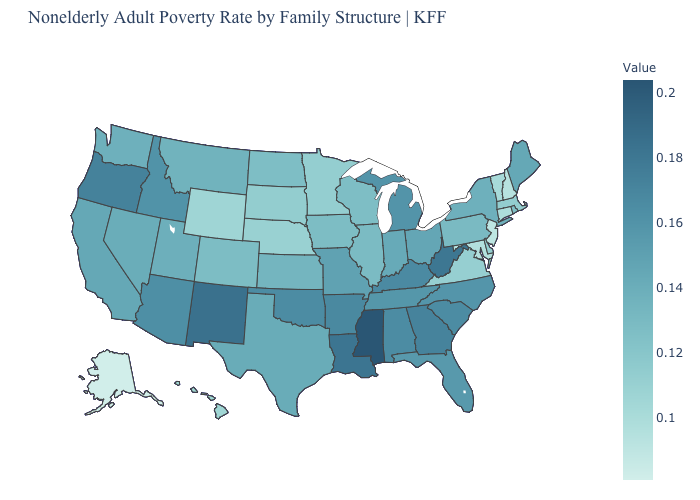Among the states that border Georgia , does North Carolina have the highest value?
Quick response, please. No. Among the states that border Massachusetts , does New Hampshire have the lowest value?
Answer briefly. Yes. Does California have a lower value than Oklahoma?
Keep it brief. Yes. Does the map have missing data?
Give a very brief answer. No. Does the map have missing data?
Be succinct. No. Does Mississippi have the highest value in the USA?
Short answer required. Yes. 